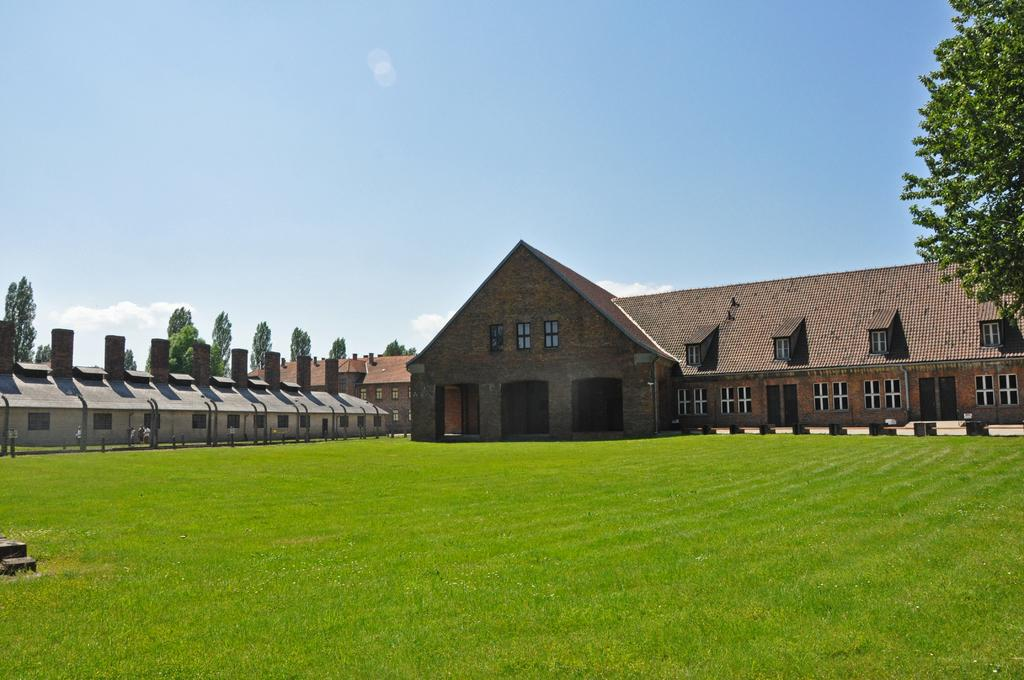What type of ground surface is visible in the image? There is grass on the ground in the image. What type of structures can be seen in the image? There are homes visible in the image. What feature can be found on the homes? There are windows on the homes. What type of vegetation is present in the image? There are trees in the image. What color is the sky in the image? The sky is blue at the top of the image. How many pies are being baked in the basket in the image? There is no basket or pies present in the image. What type of tramp can be seen interacting with the trees in the image? There is no tramp or interaction with trees in the image; only homes, windows, grass, trees, and the sky are present. 